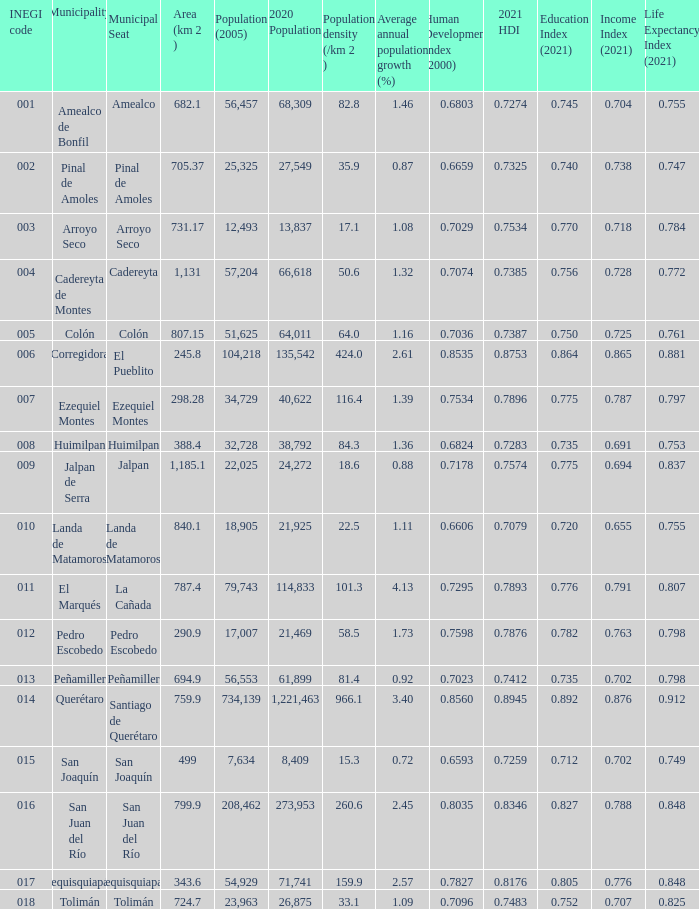I'm looking to parse the entire table for insights. Could you assist me with that? {'header': ['INEGI code', 'Municipality', 'Municipal Seat', 'Area (km 2 )', 'Population (2005)', '2020 Population', 'Population density (/km 2 )', 'Average annual population growth (%)', 'Human Development Index (2000)', '2021 HDI', 'Education Index (2021)', 'Income Index (2021)', 'Life Expectancy Index (2021)'], 'rows': [['001', 'Amealco de Bonfil', 'Amealco', '682.1', '56,457', '68,309', '82.8', '1.46', '0.6803', '0.7274', '0.745', '0.704', '0.755'], ['002', 'Pinal de Amoles', 'Pinal de Amoles', '705.37', '25,325', '27,549', '35.9', '0.87', '0.6659', '0.7325', '0.740', '0.738', '0.747'], ['003', 'Arroyo Seco', 'Arroyo Seco', '731.17', '12,493', '13,837', '17.1', '1.08', '0.7029', '0.7534', '0.770', '0.718', '0.784'], ['004', 'Cadereyta de Montes', 'Cadereyta', '1,131', '57,204', '66,618', '50.6', '1.32', '0.7074', '0.7385', '0.756', '0.728', '0.772'], ['005', 'Colón', 'Colón', '807.15', '51,625', '64,011', '64.0', '1.16', '0.7036', '0.7387', '0.750', '0.725', '0.761'], ['006', 'Corregidora', 'El Pueblito', '245.8', '104,218', '135,542', '424.0', '2.61', '0.8535', '0.8753', '0.864', '0.865', '0.881'], ['007', 'Ezequiel Montes', 'Ezequiel Montes', '298.28', '34,729', '40,622', '116.4', '1.39', '0.7534', '0.7896', '0.775', '0.787', '0.797'], ['008', 'Huimilpan', 'Huimilpan', '388.4', '32,728', '38,792', '84.3', '1.36', '0.6824', '0.7283', '0.735', '0.691', '0.753'], ['009', 'Jalpan de Serra', 'Jalpan', '1,185.1', '22,025', '24,272', '18.6', '0.88', '0.7178', '0.7574', '0.775', '0.694', '0.837'], ['010', 'Landa de Matamoros', 'Landa de Matamoros', '840.1', '18,905', '21,925', '22.5', '1.11', '0.6606', '0.7079', '0.720', '0.655', '0.755'], ['011', 'El Marqués', 'La Cañada', '787.4', '79,743', '114,833', '101.3', '4.13', '0.7295', '0.7893', '0.776', '0.791', '0.807'], ['012', 'Pedro Escobedo', 'Pedro Escobedo', '290.9', '17,007', '21,469', '58.5', '1.73', '0.7598', '0.7876', '0.782', '0.763', '0.798'], ['013', 'Peñamiller', 'Peñamiller', '694.9', '56,553', '61,899', '81.4', '0.92', '0.7023', '0.7412', '0.735', '0.702', '0.798'], ['014', 'Querétaro', 'Santiago de Querétaro', '759.9', '734,139', '1,221,463', '966.1', '3.40', '0.8560', '0.8945', '0.892', '0.876', '0.912'], ['015', 'San Joaquín', 'San Joaquín', '499', '7,634', '8,409', '15.3', '0.72', '0.6593', '0.7259', '0.712', '0.702', '0.749'], ['016', 'San Juan del Río', 'San Juan del Río', '799.9', '208,462', '273,953', '260.6', '2.45', '0.8035', '0.8346', '0.827', '0.788', '0.848'], ['017', 'Tequisquiapan', 'Tequisquiapan', '343.6', '54,929', '71,741', '159.9', '2.57', '0.7827', '0.8176', '0.805', '0.776', '0.848'], ['018', 'Tolimán', 'Tolimán', '724.7', '23,963', '26,875', '33.1', '1.09', '0.7096', '0.7483', '0.752', '0.707', '0.825']]} WHat is the amount of Human Development Index (2000) that has a Population (2005) of 54,929, and an Area (km 2 ) larger than 343.6? 0.0. 